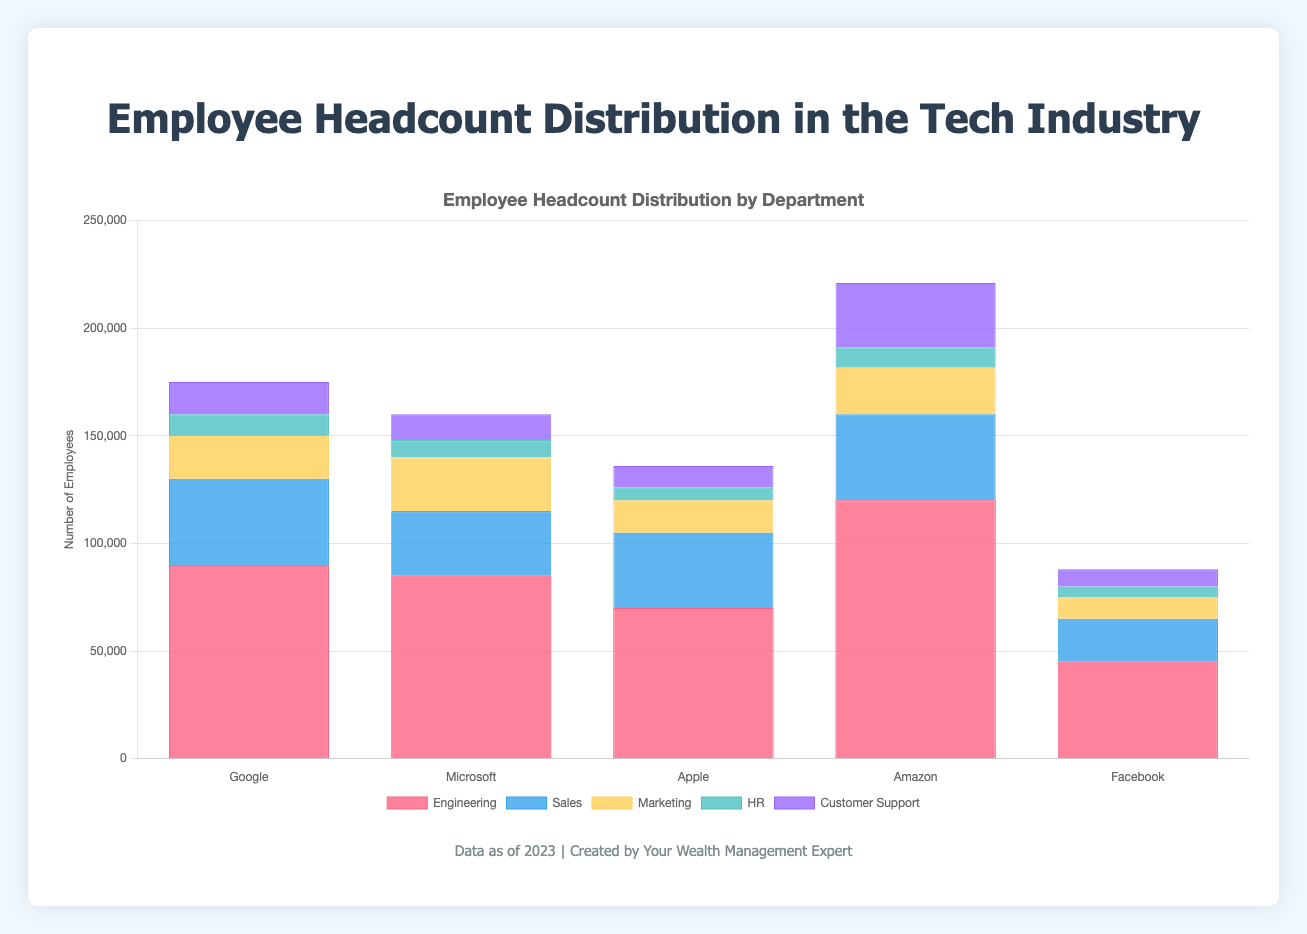Which company has the highest total headcount? By summing up the headcounts of all departments in each company, we see that Amazon has the highest total headcount: Engineering (120,000) + Sales (40,000) + Marketing (22,000) + HR (9,000) + Customer Support (30,000) = 221,000.
Answer: Amazon Which department across all companies has the largest total headcount? Adding up the headcounts of all departments across all companies, Engineering has the largest total headcount: Google (90,000) + Microsoft (85,000) + Apple (70,000) + Amazon (120,000) + Facebook (45,000) = 410,000.
Answer: Engineering How does Google's total headcount compare to Microsoft's? Google's total headcount is 170,000, calculated as the sum of: Engineering (90,000) + Sales (40,000) + Marketing (20,000) + HR (10,000) + Customer Support (15,000). Microsoft's total headcount is 160,000, calculated as the sum of: Engineering (85,000) + Sales (30,000) + Marketing (25,000) + HR (8,000) + Customer Support (12,000). Thus, Google's headcount is greater than Microsoft's by 170,000 - 160,000 = 10,000.
Answer: Google has 10,000 more employees than Microsoft Which company has the smallest headcount in the Marketing department? For the Marketing department: Google has 20,000, Microsoft has 25,000, Apple has 15,000, Amazon has 22,000, and Facebook has 10,000. Therefore, Facebook has the smallest Marketing headcount.
Answer: Facebook What's the total headcount in the HR departments for all companies combined? Adding up the HR headcounts: Google (10,000) + Microsoft (8,000) + Apple (6,000) + Amazon (9,000) + Facebook (5,000) = 38,000.
Answer: 38,000 What is the total headcount for Sales and Customer Support combined across all companies? Adding headcounts for both departments: Sales: Google (40,000) + Microsoft (30,000) + Apple (35,000) + Amazon (40,000) + Facebook (20,000) = 165,000, Customer Support: Google (15,000) + Microsoft (12,000) + Apple (10,000) + Amazon (30,000) + Facebook (8,000) = 75,000, Total combined: 165,000 + 75,000 = 240,000.
Answer: 240,000 Considering only the HR and Customer Support departments, which company has the highest combined headcount? For Google: HR (10,000) + Customer Support (15,000) = 25,000; for Microsoft: HR (8,000) + Customer Support (12,000) = 20,000; for Apple: HR (6,000) + Customer Support (10,000) = 16,000; for Amazon: HR (9,000) + Customer Support (30,000) = 39,000; for Facebook: HR (5,000) + Customer Support (8,000) = 13,000. Amazon has the highest combined headcount with 39,000.
Answer: Amazon Which department has the smallest headcount at Apple? Apple's smallest department is HR with 6,000 employees.
Answer: HR What's the difference in headcount between the Engineering and Marketing departments at Amazon? Amazon's Engineering department has 120,000 employees, and the Marketing department has 22,000 employees. The difference is 120,000 - 22,000 = 98,000.
Answer: 98,000 How does Amazon's Customer Support headcount compare to that of Facebook? Amazon's Customer Support headcount is 30,000, while Facebook's is 8,000. Thus, Amazon's headcount is larger by 30,000 - 8,000 = 22,000.
Answer: Amazon has 22,000 more Customer Support employees than Facebook 